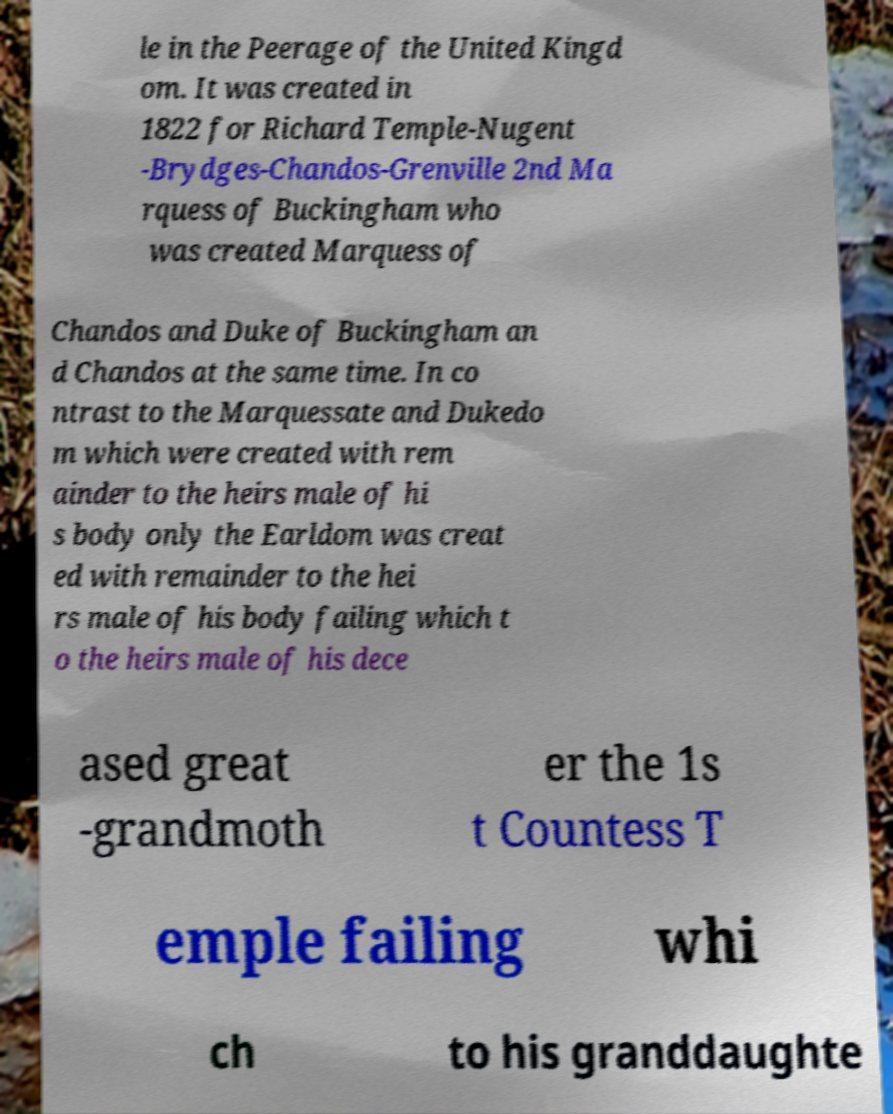For documentation purposes, I need the text within this image transcribed. Could you provide that? le in the Peerage of the United Kingd om. It was created in 1822 for Richard Temple-Nugent -Brydges-Chandos-Grenville 2nd Ma rquess of Buckingham who was created Marquess of Chandos and Duke of Buckingham an d Chandos at the same time. In co ntrast to the Marquessate and Dukedo m which were created with rem ainder to the heirs male of hi s body only the Earldom was creat ed with remainder to the hei rs male of his body failing which t o the heirs male of his dece ased great -grandmoth er the 1s t Countess T emple failing whi ch to his granddaughte 